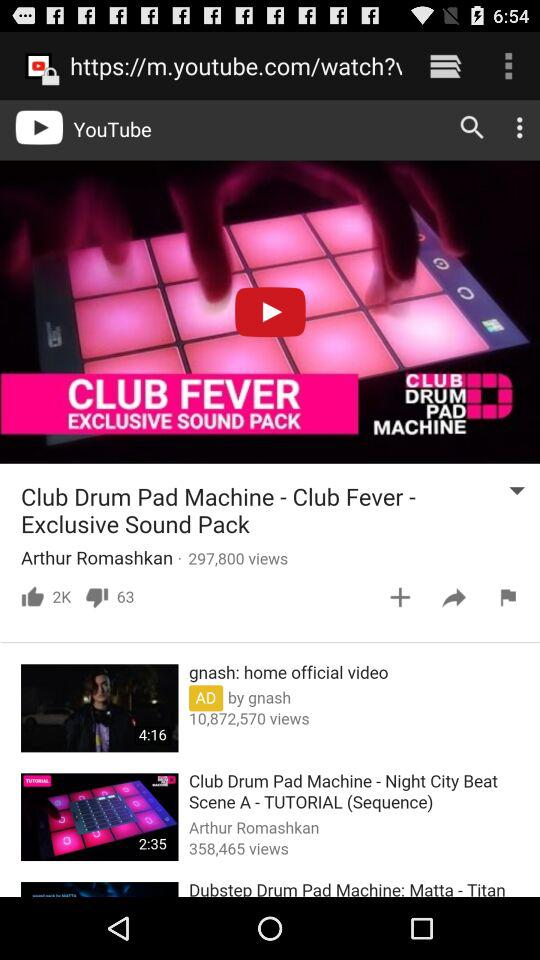How many views are there for "Club Drum Pad Machine - Night City Beat"? There are 358,465 views. 